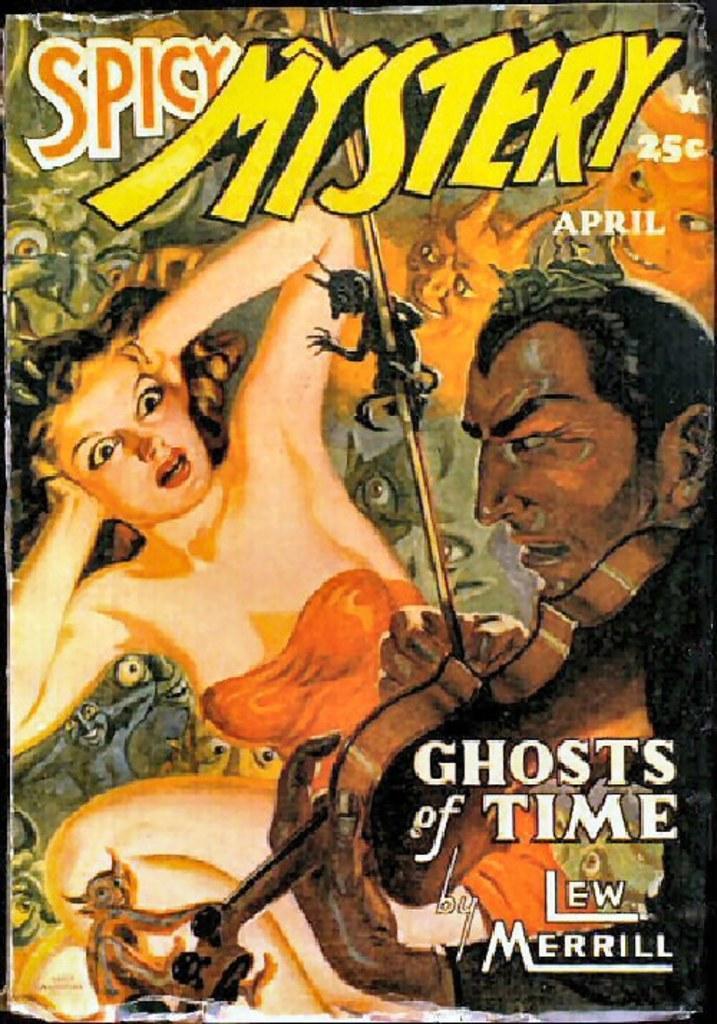Describe this image in one or two sentences. This is an edited image. In the center we can see a picture of a woman seems to be sitting on the ground. On the right there is a picture of a person playing violin and there are some animals and we can see the text is printed on the picture. 